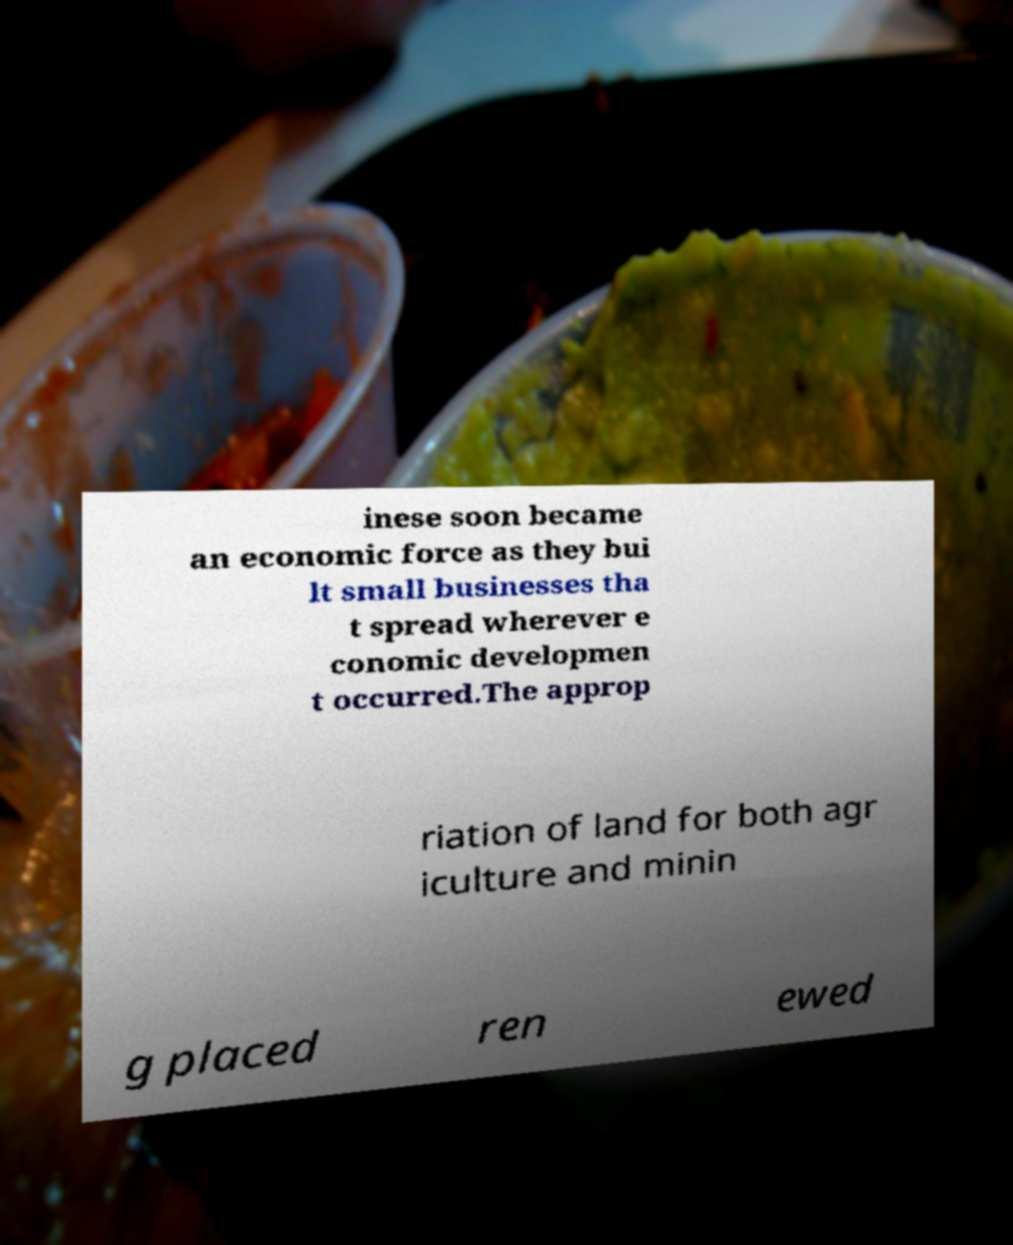What messages or text are displayed in this image? I need them in a readable, typed format. inese soon became an economic force as they bui lt small businesses tha t spread wherever e conomic developmen t occurred.The approp riation of land for both agr iculture and minin g placed ren ewed 